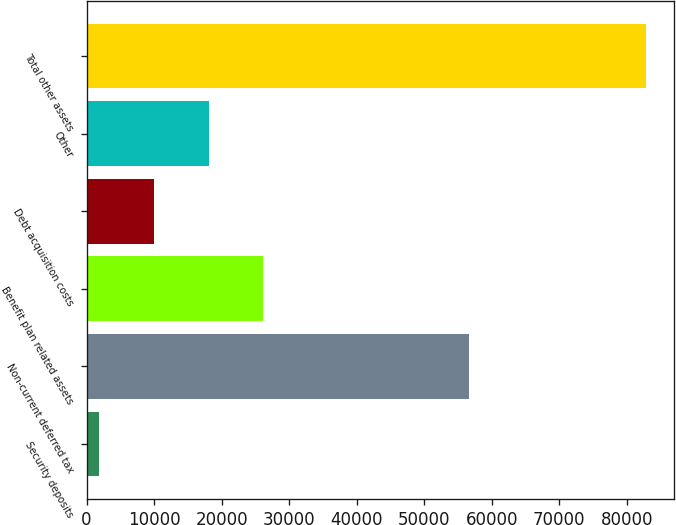<chart> <loc_0><loc_0><loc_500><loc_500><bar_chart><fcel>Security deposits<fcel>Non-current deferred tax<fcel>Benefit plan related assets<fcel>Debt acquisition costs<fcel>Other<fcel>Total other assets<nl><fcel>1862<fcel>56627<fcel>26173.7<fcel>9965.9<fcel>18069.8<fcel>82901<nl></chart> 